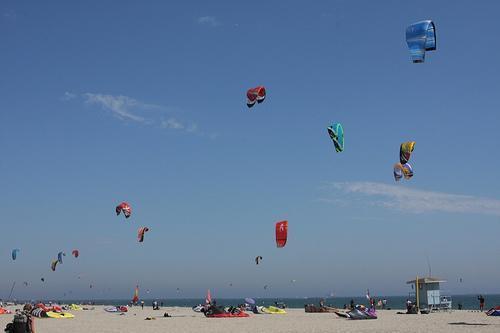How many lifeguard stands?
Give a very brief answer. 1. How many clouds?
Give a very brief answer. 2. How many women on bikes are in the picture?
Give a very brief answer. 0. 